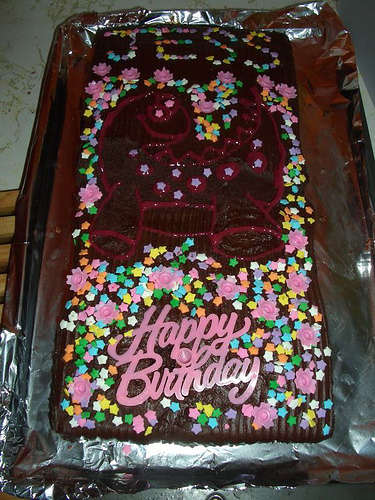<image>
Can you confirm if the cake is above the bench? Yes. The cake is positioned above the bench in the vertical space, higher up in the scene. 